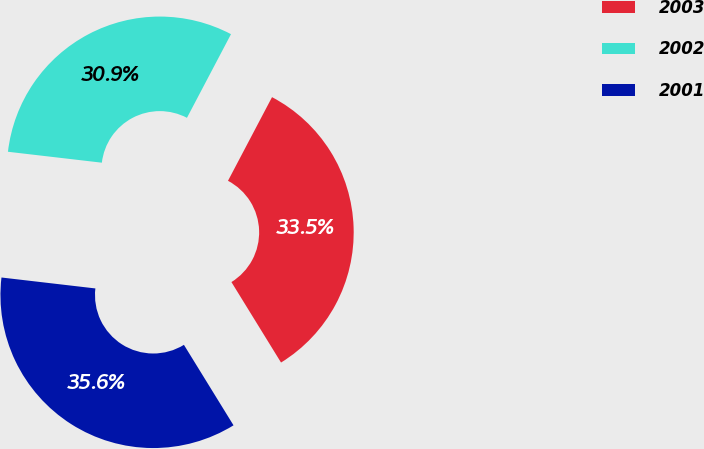Convert chart to OTSL. <chart><loc_0><loc_0><loc_500><loc_500><pie_chart><fcel>2003<fcel>2002<fcel>2001<nl><fcel>33.5%<fcel>30.87%<fcel>35.64%<nl></chart> 